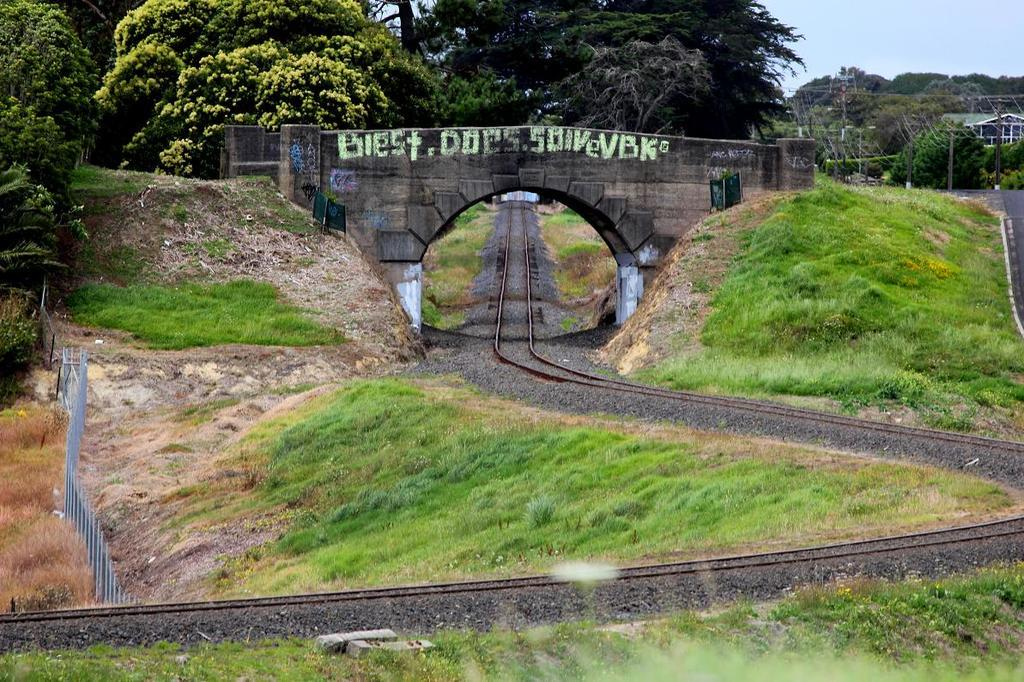<image>
Offer a succinct explanation of the picture presented. A stone bridge is painted with words beginning with "biest.." 